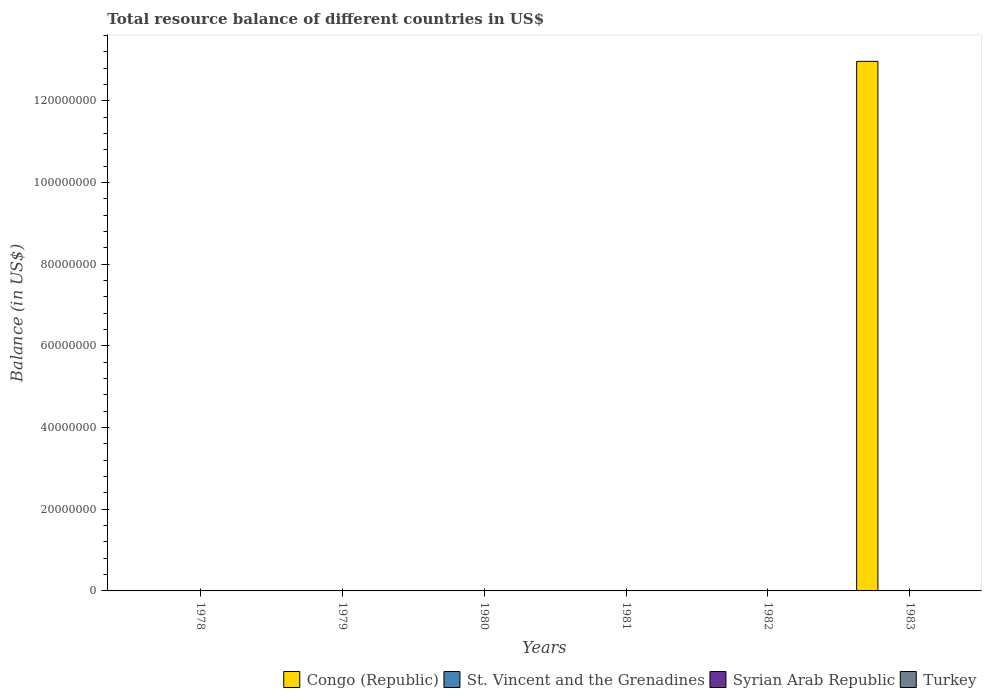How many different coloured bars are there?
Offer a terse response. 1. Are the number of bars on each tick of the X-axis equal?
Your answer should be very brief. No. How many bars are there on the 4th tick from the right?
Offer a very short reply. 0. What is the total resource balance in Turkey in 1978?
Give a very brief answer. 0. Across all years, what is the maximum total resource balance in Congo (Republic)?
Offer a very short reply. 1.30e+08. Across all years, what is the minimum total resource balance in Congo (Republic)?
Your answer should be compact. 0. What is the average total resource balance in Turkey per year?
Your answer should be very brief. 0. What is the difference between the highest and the lowest total resource balance in Congo (Republic)?
Provide a succinct answer. 1.30e+08. How many bars are there?
Offer a very short reply. 1. Are all the bars in the graph horizontal?
Provide a short and direct response. No. How many years are there in the graph?
Keep it short and to the point. 6. Does the graph contain any zero values?
Offer a terse response. Yes. Does the graph contain grids?
Your answer should be compact. No. How many legend labels are there?
Your response must be concise. 4. How are the legend labels stacked?
Your answer should be very brief. Horizontal. What is the title of the graph?
Ensure brevity in your answer.  Total resource balance of different countries in US$. What is the label or title of the X-axis?
Provide a short and direct response. Years. What is the label or title of the Y-axis?
Provide a succinct answer. Balance (in US$). What is the Balance (in US$) of St. Vincent and the Grenadines in 1978?
Provide a short and direct response. 0. What is the Balance (in US$) in Congo (Republic) in 1979?
Provide a short and direct response. 0. What is the Balance (in US$) in St. Vincent and the Grenadines in 1979?
Make the answer very short. 0. What is the Balance (in US$) in Turkey in 1979?
Give a very brief answer. 0. What is the Balance (in US$) in St. Vincent and the Grenadines in 1980?
Ensure brevity in your answer.  0. What is the Balance (in US$) of Syrian Arab Republic in 1980?
Give a very brief answer. 0. What is the Balance (in US$) in Congo (Republic) in 1981?
Your response must be concise. 0. What is the Balance (in US$) in Congo (Republic) in 1982?
Provide a short and direct response. 0. What is the Balance (in US$) of Syrian Arab Republic in 1982?
Your answer should be very brief. 0. What is the Balance (in US$) of Congo (Republic) in 1983?
Provide a succinct answer. 1.30e+08. Across all years, what is the maximum Balance (in US$) of Congo (Republic)?
Offer a terse response. 1.30e+08. What is the total Balance (in US$) of Congo (Republic) in the graph?
Ensure brevity in your answer.  1.30e+08. What is the average Balance (in US$) of Congo (Republic) per year?
Keep it short and to the point. 2.16e+07. What is the average Balance (in US$) of St. Vincent and the Grenadines per year?
Provide a short and direct response. 0. What is the average Balance (in US$) in Syrian Arab Republic per year?
Provide a short and direct response. 0. What is the difference between the highest and the lowest Balance (in US$) in Congo (Republic)?
Provide a succinct answer. 1.30e+08. 